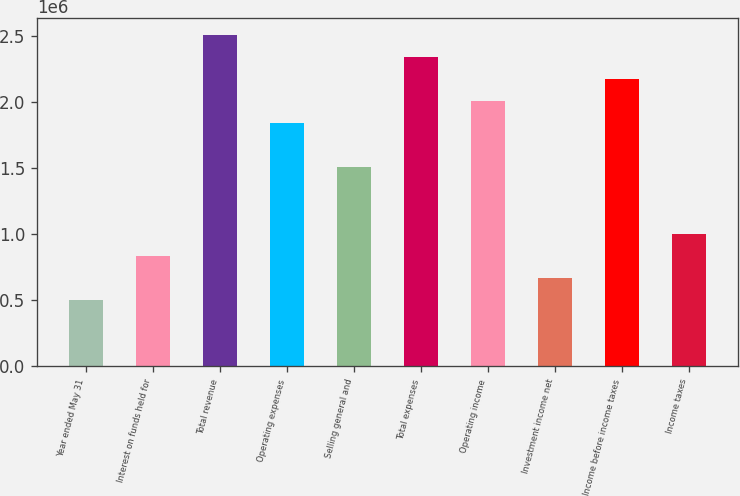<chart> <loc_0><loc_0><loc_500><loc_500><bar_chart><fcel>Year ended May 31<fcel>Interest on funds held for<fcel>Total revenue<fcel>Operating expenses<fcel>Selling general and<fcel>Total expenses<fcel>Operating income<fcel>Investment income net<fcel>Income before income taxes<fcel>Income taxes<nl><fcel>502379<fcel>837298<fcel>2.51189e+06<fcel>1.84206e+06<fcel>1.50714e+06<fcel>2.34443e+06<fcel>2.00952e+06<fcel>669839<fcel>2.17697e+06<fcel>1.00476e+06<nl></chart> 